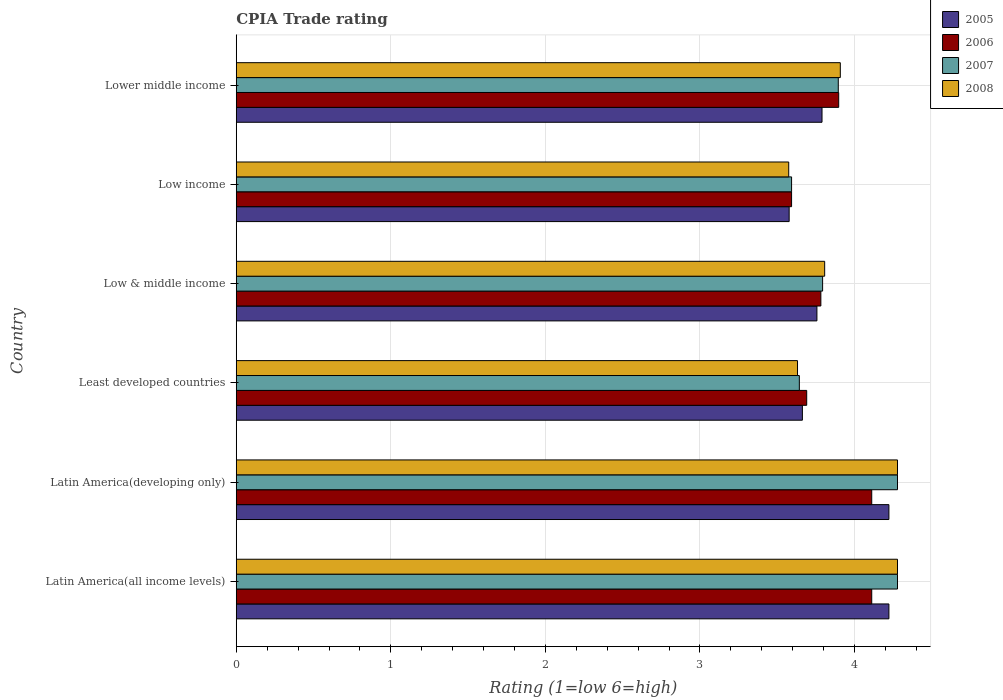Are the number of bars per tick equal to the number of legend labels?
Your answer should be compact. Yes. Are the number of bars on each tick of the Y-axis equal?
Make the answer very short. Yes. How many bars are there on the 5th tick from the top?
Provide a succinct answer. 4. How many bars are there on the 3rd tick from the bottom?
Ensure brevity in your answer.  4. What is the label of the 5th group of bars from the top?
Provide a short and direct response. Latin America(developing only). In how many cases, is the number of bars for a given country not equal to the number of legend labels?
Your answer should be compact. 0. What is the CPIA rating in 2008 in Latin America(all income levels)?
Keep it short and to the point. 4.28. Across all countries, what is the maximum CPIA rating in 2008?
Provide a succinct answer. 4.28. Across all countries, what is the minimum CPIA rating in 2005?
Make the answer very short. 3.58. In which country was the CPIA rating in 2007 maximum?
Provide a succinct answer. Latin America(all income levels). In which country was the CPIA rating in 2005 minimum?
Your answer should be very brief. Low income. What is the total CPIA rating in 2006 in the graph?
Offer a terse response. 23.18. What is the difference between the CPIA rating in 2008 in Low & middle income and that in Low income?
Your response must be concise. 0.23. What is the difference between the CPIA rating in 2007 in Lower middle income and the CPIA rating in 2006 in Low & middle income?
Ensure brevity in your answer.  0.11. What is the average CPIA rating in 2007 per country?
Offer a terse response. 3.91. What is the difference between the CPIA rating in 2007 and CPIA rating in 2008 in Latin America(developing only)?
Provide a short and direct response. 0. What is the ratio of the CPIA rating in 2007 in Low & middle income to that in Lower middle income?
Give a very brief answer. 0.97. Is the CPIA rating in 2005 in Latin America(developing only) less than that in Low income?
Your answer should be very brief. No. Is the difference between the CPIA rating in 2007 in Latin America(all income levels) and Low & middle income greater than the difference between the CPIA rating in 2008 in Latin America(all income levels) and Low & middle income?
Make the answer very short. Yes. What is the difference between the highest and the second highest CPIA rating in 2008?
Your answer should be compact. 0. What is the difference between the highest and the lowest CPIA rating in 2006?
Your answer should be compact. 0.52. In how many countries, is the CPIA rating in 2005 greater than the average CPIA rating in 2005 taken over all countries?
Make the answer very short. 2. Is the sum of the CPIA rating in 2006 in Latin America(developing only) and Least developed countries greater than the maximum CPIA rating in 2005 across all countries?
Your answer should be very brief. Yes. How many bars are there?
Your answer should be very brief. 24. How many countries are there in the graph?
Offer a terse response. 6. Does the graph contain any zero values?
Ensure brevity in your answer.  No. How many legend labels are there?
Keep it short and to the point. 4. How are the legend labels stacked?
Keep it short and to the point. Vertical. What is the title of the graph?
Offer a terse response. CPIA Trade rating. Does "1984" appear as one of the legend labels in the graph?
Your response must be concise. No. What is the label or title of the X-axis?
Provide a short and direct response. Rating (1=low 6=high). What is the Rating (1=low 6=high) in 2005 in Latin America(all income levels)?
Give a very brief answer. 4.22. What is the Rating (1=low 6=high) in 2006 in Latin America(all income levels)?
Give a very brief answer. 4.11. What is the Rating (1=low 6=high) in 2007 in Latin America(all income levels)?
Offer a very short reply. 4.28. What is the Rating (1=low 6=high) of 2008 in Latin America(all income levels)?
Ensure brevity in your answer.  4.28. What is the Rating (1=low 6=high) of 2005 in Latin America(developing only)?
Provide a succinct answer. 4.22. What is the Rating (1=low 6=high) of 2006 in Latin America(developing only)?
Your answer should be compact. 4.11. What is the Rating (1=low 6=high) of 2007 in Latin America(developing only)?
Make the answer very short. 4.28. What is the Rating (1=low 6=high) of 2008 in Latin America(developing only)?
Provide a succinct answer. 4.28. What is the Rating (1=low 6=high) of 2005 in Least developed countries?
Offer a very short reply. 3.66. What is the Rating (1=low 6=high) of 2006 in Least developed countries?
Give a very brief answer. 3.69. What is the Rating (1=low 6=high) of 2007 in Least developed countries?
Keep it short and to the point. 3.64. What is the Rating (1=low 6=high) of 2008 in Least developed countries?
Offer a very short reply. 3.63. What is the Rating (1=low 6=high) of 2005 in Low & middle income?
Ensure brevity in your answer.  3.76. What is the Rating (1=low 6=high) in 2006 in Low & middle income?
Offer a very short reply. 3.78. What is the Rating (1=low 6=high) of 2007 in Low & middle income?
Give a very brief answer. 3.79. What is the Rating (1=low 6=high) in 2008 in Low & middle income?
Your answer should be compact. 3.81. What is the Rating (1=low 6=high) in 2005 in Low income?
Provide a short and direct response. 3.58. What is the Rating (1=low 6=high) in 2006 in Low income?
Ensure brevity in your answer.  3.59. What is the Rating (1=low 6=high) in 2007 in Low income?
Your response must be concise. 3.59. What is the Rating (1=low 6=high) of 2008 in Low income?
Offer a very short reply. 3.57. What is the Rating (1=low 6=high) of 2005 in Lower middle income?
Your response must be concise. 3.79. What is the Rating (1=low 6=high) of 2006 in Lower middle income?
Give a very brief answer. 3.9. What is the Rating (1=low 6=high) of 2007 in Lower middle income?
Offer a very short reply. 3.89. What is the Rating (1=low 6=high) in 2008 in Lower middle income?
Provide a succinct answer. 3.91. Across all countries, what is the maximum Rating (1=low 6=high) in 2005?
Offer a very short reply. 4.22. Across all countries, what is the maximum Rating (1=low 6=high) in 2006?
Offer a very short reply. 4.11. Across all countries, what is the maximum Rating (1=low 6=high) of 2007?
Your response must be concise. 4.28. Across all countries, what is the maximum Rating (1=low 6=high) of 2008?
Offer a very short reply. 4.28. Across all countries, what is the minimum Rating (1=low 6=high) of 2005?
Provide a succinct answer. 3.58. Across all countries, what is the minimum Rating (1=low 6=high) of 2006?
Provide a succinct answer. 3.59. Across all countries, what is the minimum Rating (1=low 6=high) of 2007?
Provide a short and direct response. 3.59. Across all countries, what is the minimum Rating (1=low 6=high) in 2008?
Keep it short and to the point. 3.57. What is the total Rating (1=low 6=high) in 2005 in the graph?
Make the answer very short. 23.23. What is the total Rating (1=low 6=high) in 2006 in the graph?
Make the answer very short. 23.18. What is the total Rating (1=low 6=high) in 2007 in the graph?
Your response must be concise. 23.48. What is the total Rating (1=low 6=high) in 2008 in the graph?
Your answer should be very brief. 23.48. What is the difference between the Rating (1=low 6=high) in 2005 in Latin America(all income levels) and that in Latin America(developing only)?
Provide a succinct answer. 0. What is the difference between the Rating (1=low 6=high) of 2006 in Latin America(all income levels) and that in Latin America(developing only)?
Provide a short and direct response. 0. What is the difference between the Rating (1=low 6=high) in 2008 in Latin America(all income levels) and that in Latin America(developing only)?
Offer a terse response. 0. What is the difference between the Rating (1=low 6=high) in 2005 in Latin America(all income levels) and that in Least developed countries?
Offer a terse response. 0.56. What is the difference between the Rating (1=low 6=high) of 2006 in Latin America(all income levels) and that in Least developed countries?
Make the answer very short. 0.42. What is the difference between the Rating (1=low 6=high) in 2007 in Latin America(all income levels) and that in Least developed countries?
Offer a terse response. 0.63. What is the difference between the Rating (1=low 6=high) in 2008 in Latin America(all income levels) and that in Least developed countries?
Provide a succinct answer. 0.65. What is the difference between the Rating (1=low 6=high) in 2005 in Latin America(all income levels) and that in Low & middle income?
Your answer should be compact. 0.47. What is the difference between the Rating (1=low 6=high) of 2006 in Latin America(all income levels) and that in Low & middle income?
Offer a very short reply. 0.33. What is the difference between the Rating (1=low 6=high) in 2007 in Latin America(all income levels) and that in Low & middle income?
Your response must be concise. 0.48. What is the difference between the Rating (1=low 6=high) of 2008 in Latin America(all income levels) and that in Low & middle income?
Give a very brief answer. 0.47. What is the difference between the Rating (1=low 6=high) of 2005 in Latin America(all income levels) and that in Low income?
Make the answer very short. 0.65. What is the difference between the Rating (1=low 6=high) of 2006 in Latin America(all income levels) and that in Low income?
Your answer should be very brief. 0.52. What is the difference between the Rating (1=low 6=high) in 2007 in Latin America(all income levels) and that in Low income?
Offer a terse response. 0.69. What is the difference between the Rating (1=low 6=high) of 2008 in Latin America(all income levels) and that in Low income?
Provide a succinct answer. 0.7. What is the difference between the Rating (1=low 6=high) of 2005 in Latin America(all income levels) and that in Lower middle income?
Offer a very short reply. 0.43. What is the difference between the Rating (1=low 6=high) in 2006 in Latin America(all income levels) and that in Lower middle income?
Offer a terse response. 0.21. What is the difference between the Rating (1=low 6=high) in 2007 in Latin America(all income levels) and that in Lower middle income?
Keep it short and to the point. 0.38. What is the difference between the Rating (1=low 6=high) of 2008 in Latin America(all income levels) and that in Lower middle income?
Offer a very short reply. 0.37. What is the difference between the Rating (1=low 6=high) in 2005 in Latin America(developing only) and that in Least developed countries?
Your answer should be compact. 0.56. What is the difference between the Rating (1=low 6=high) in 2006 in Latin America(developing only) and that in Least developed countries?
Provide a short and direct response. 0.42. What is the difference between the Rating (1=low 6=high) of 2007 in Latin America(developing only) and that in Least developed countries?
Give a very brief answer. 0.63. What is the difference between the Rating (1=low 6=high) in 2008 in Latin America(developing only) and that in Least developed countries?
Give a very brief answer. 0.65. What is the difference between the Rating (1=low 6=high) in 2005 in Latin America(developing only) and that in Low & middle income?
Your answer should be very brief. 0.47. What is the difference between the Rating (1=low 6=high) of 2006 in Latin America(developing only) and that in Low & middle income?
Provide a succinct answer. 0.33. What is the difference between the Rating (1=low 6=high) in 2007 in Latin America(developing only) and that in Low & middle income?
Keep it short and to the point. 0.48. What is the difference between the Rating (1=low 6=high) in 2008 in Latin America(developing only) and that in Low & middle income?
Provide a short and direct response. 0.47. What is the difference between the Rating (1=low 6=high) of 2005 in Latin America(developing only) and that in Low income?
Your answer should be compact. 0.65. What is the difference between the Rating (1=low 6=high) in 2006 in Latin America(developing only) and that in Low income?
Provide a succinct answer. 0.52. What is the difference between the Rating (1=low 6=high) in 2007 in Latin America(developing only) and that in Low income?
Provide a succinct answer. 0.69. What is the difference between the Rating (1=low 6=high) of 2008 in Latin America(developing only) and that in Low income?
Offer a terse response. 0.7. What is the difference between the Rating (1=low 6=high) in 2005 in Latin America(developing only) and that in Lower middle income?
Give a very brief answer. 0.43. What is the difference between the Rating (1=low 6=high) of 2006 in Latin America(developing only) and that in Lower middle income?
Offer a terse response. 0.21. What is the difference between the Rating (1=low 6=high) of 2007 in Latin America(developing only) and that in Lower middle income?
Keep it short and to the point. 0.38. What is the difference between the Rating (1=low 6=high) of 2008 in Latin America(developing only) and that in Lower middle income?
Provide a short and direct response. 0.37. What is the difference between the Rating (1=low 6=high) in 2005 in Least developed countries and that in Low & middle income?
Provide a short and direct response. -0.09. What is the difference between the Rating (1=low 6=high) in 2006 in Least developed countries and that in Low & middle income?
Your response must be concise. -0.09. What is the difference between the Rating (1=low 6=high) of 2007 in Least developed countries and that in Low & middle income?
Give a very brief answer. -0.15. What is the difference between the Rating (1=low 6=high) in 2008 in Least developed countries and that in Low & middle income?
Provide a succinct answer. -0.18. What is the difference between the Rating (1=low 6=high) in 2005 in Least developed countries and that in Low income?
Offer a terse response. 0.09. What is the difference between the Rating (1=low 6=high) in 2006 in Least developed countries and that in Low income?
Offer a terse response. 0.1. What is the difference between the Rating (1=low 6=high) of 2007 in Least developed countries and that in Low income?
Offer a very short reply. 0.05. What is the difference between the Rating (1=low 6=high) of 2008 in Least developed countries and that in Low income?
Offer a terse response. 0.06. What is the difference between the Rating (1=low 6=high) of 2005 in Least developed countries and that in Lower middle income?
Provide a short and direct response. -0.13. What is the difference between the Rating (1=low 6=high) of 2006 in Least developed countries and that in Lower middle income?
Provide a succinct answer. -0.21. What is the difference between the Rating (1=low 6=high) in 2007 in Least developed countries and that in Lower middle income?
Your answer should be very brief. -0.25. What is the difference between the Rating (1=low 6=high) of 2008 in Least developed countries and that in Lower middle income?
Make the answer very short. -0.28. What is the difference between the Rating (1=low 6=high) in 2005 in Low & middle income and that in Low income?
Offer a terse response. 0.18. What is the difference between the Rating (1=low 6=high) in 2006 in Low & middle income and that in Low income?
Make the answer very short. 0.19. What is the difference between the Rating (1=low 6=high) of 2007 in Low & middle income and that in Low income?
Give a very brief answer. 0.2. What is the difference between the Rating (1=low 6=high) in 2008 in Low & middle income and that in Low income?
Keep it short and to the point. 0.23. What is the difference between the Rating (1=low 6=high) of 2005 in Low & middle income and that in Lower middle income?
Make the answer very short. -0.03. What is the difference between the Rating (1=low 6=high) of 2006 in Low & middle income and that in Lower middle income?
Offer a terse response. -0.12. What is the difference between the Rating (1=low 6=high) in 2007 in Low & middle income and that in Lower middle income?
Your response must be concise. -0.1. What is the difference between the Rating (1=low 6=high) of 2008 in Low & middle income and that in Lower middle income?
Offer a terse response. -0.1. What is the difference between the Rating (1=low 6=high) in 2005 in Low income and that in Lower middle income?
Your answer should be very brief. -0.21. What is the difference between the Rating (1=low 6=high) of 2006 in Low income and that in Lower middle income?
Ensure brevity in your answer.  -0.3. What is the difference between the Rating (1=low 6=high) of 2007 in Low income and that in Lower middle income?
Give a very brief answer. -0.3. What is the difference between the Rating (1=low 6=high) in 2008 in Low income and that in Lower middle income?
Keep it short and to the point. -0.33. What is the difference between the Rating (1=low 6=high) in 2005 in Latin America(all income levels) and the Rating (1=low 6=high) in 2007 in Latin America(developing only)?
Offer a terse response. -0.06. What is the difference between the Rating (1=low 6=high) in 2005 in Latin America(all income levels) and the Rating (1=low 6=high) in 2008 in Latin America(developing only)?
Give a very brief answer. -0.06. What is the difference between the Rating (1=low 6=high) in 2006 in Latin America(all income levels) and the Rating (1=low 6=high) in 2007 in Latin America(developing only)?
Keep it short and to the point. -0.17. What is the difference between the Rating (1=low 6=high) of 2007 in Latin America(all income levels) and the Rating (1=low 6=high) of 2008 in Latin America(developing only)?
Provide a short and direct response. 0. What is the difference between the Rating (1=low 6=high) of 2005 in Latin America(all income levels) and the Rating (1=low 6=high) of 2006 in Least developed countries?
Offer a terse response. 0.53. What is the difference between the Rating (1=low 6=high) in 2005 in Latin America(all income levels) and the Rating (1=low 6=high) in 2007 in Least developed countries?
Give a very brief answer. 0.58. What is the difference between the Rating (1=low 6=high) in 2005 in Latin America(all income levels) and the Rating (1=low 6=high) in 2008 in Least developed countries?
Provide a short and direct response. 0.59. What is the difference between the Rating (1=low 6=high) in 2006 in Latin America(all income levels) and the Rating (1=low 6=high) in 2007 in Least developed countries?
Provide a succinct answer. 0.47. What is the difference between the Rating (1=low 6=high) of 2006 in Latin America(all income levels) and the Rating (1=low 6=high) of 2008 in Least developed countries?
Your answer should be compact. 0.48. What is the difference between the Rating (1=low 6=high) of 2007 in Latin America(all income levels) and the Rating (1=low 6=high) of 2008 in Least developed countries?
Give a very brief answer. 0.65. What is the difference between the Rating (1=low 6=high) in 2005 in Latin America(all income levels) and the Rating (1=low 6=high) in 2006 in Low & middle income?
Provide a succinct answer. 0.44. What is the difference between the Rating (1=low 6=high) of 2005 in Latin America(all income levels) and the Rating (1=low 6=high) of 2007 in Low & middle income?
Keep it short and to the point. 0.43. What is the difference between the Rating (1=low 6=high) in 2005 in Latin America(all income levels) and the Rating (1=low 6=high) in 2008 in Low & middle income?
Your answer should be very brief. 0.42. What is the difference between the Rating (1=low 6=high) in 2006 in Latin America(all income levels) and the Rating (1=low 6=high) in 2007 in Low & middle income?
Your answer should be compact. 0.32. What is the difference between the Rating (1=low 6=high) in 2006 in Latin America(all income levels) and the Rating (1=low 6=high) in 2008 in Low & middle income?
Your response must be concise. 0.3. What is the difference between the Rating (1=low 6=high) in 2007 in Latin America(all income levels) and the Rating (1=low 6=high) in 2008 in Low & middle income?
Your answer should be very brief. 0.47. What is the difference between the Rating (1=low 6=high) in 2005 in Latin America(all income levels) and the Rating (1=low 6=high) in 2006 in Low income?
Give a very brief answer. 0.63. What is the difference between the Rating (1=low 6=high) of 2005 in Latin America(all income levels) and the Rating (1=low 6=high) of 2007 in Low income?
Provide a succinct answer. 0.63. What is the difference between the Rating (1=low 6=high) of 2005 in Latin America(all income levels) and the Rating (1=low 6=high) of 2008 in Low income?
Offer a very short reply. 0.65. What is the difference between the Rating (1=low 6=high) in 2006 in Latin America(all income levels) and the Rating (1=low 6=high) in 2007 in Low income?
Make the answer very short. 0.52. What is the difference between the Rating (1=low 6=high) in 2006 in Latin America(all income levels) and the Rating (1=low 6=high) in 2008 in Low income?
Offer a very short reply. 0.54. What is the difference between the Rating (1=low 6=high) in 2007 in Latin America(all income levels) and the Rating (1=low 6=high) in 2008 in Low income?
Provide a succinct answer. 0.7. What is the difference between the Rating (1=low 6=high) of 2005 in Latin America(all income levels) and the Rating (1=low 6=high) of 2006 in Lower middle income?
Ensure brevity in your answer.  0.32. What is the difference between the Rating (1=low 6=high) in 2005 in Latin America(all income levels) and the Rating (1=low 6=high) in 2007 in Lower middle income?
Provide a short and direct response. 0.33. What is the difference between the Rating (1=low 6=high) of 2005 in Latin America(all income levels) and the Rating (1=low 6=high) of 2008 in Lower middle income?
Ensure brevity in your answer.  0.31. What is the difference between the Rating (1=low 6=high) of 2006 in Latin America(all income levels) and the Rating (1=low 6=high) of 2007 in Lower middle income?
Your response must be concise. 0.22. What is the difference between the Rating (1=low 6=high) of 2006 in Latin America(all income levels) and the Rating (1=low 6=high) of 2008 in Lower middle income?
Offer a terse response. 0.2. What is the difference between the Rating (1=low 6=high) of 2007 in Latin America(all income levels) and the Rating (1=low 6=high) of 2008 in Lower middle income?
Your answer should be compact. 0.37. What is the difference between the Rating (1=low 6=high) of 2005 in Latin America(developing only) and the Rating (1=low 6=high) of 2006 in Least developed countries?
Make the answer very short. 0.53. What is the difference between the Rating (1=low 6=high) in 2005 in Latin America(developing only) and the Rating (1=low 6=high) in 2007 in Least developed countries?
Give a very brief answer. 0.58. What is the difference between the Rating (1=low 6=high) of 2005 in Latin America(developing only) and the Rating (1=low 6=high) of 2008 in Least developed countries?
Your response must be concise. 0.59. What is the difference between the Rating (1=low 6=high) of 2006 in Latin America(developing only) and the Rating (1=low 6=high) of 2007 in Least developed countries?
Your answer should be compact. 0.47. What is the difference between the Rating (1=low 6=high) in 2006 in Latin America(developing only) and the Rating (1=low 6=high) in 2008 in Least developed countries?
Offer a very short reply. 0.48. What is the difference between the Rating (1=low 6=high) of 2007 in Latin America(developing only) and the Rating (1=low 6=high) of 2008 in Least developed countries?
Your answer should be compact. 0.65. What is the difference between the Rating (1=low 6=high) of 2005 in Latin America(developing only) and the Rating (1=low 6=high) of 2006 in Low & middle income?
Your answer should be very brief. 0.44. What is the difference between the Rating (1=low 6=high) in 2005 in Latin America(developing only) and the Rating (1=low 6=high) in 2007 in Low & middle income?
Your answer should be compact. 0.43. What is the difference between the Rating (1=low 6=high) of 2005 in Latin America(developing only) and the Rating (1=low 6=high) of 2008 in Low & middle income?
Your answer should be compact. 0.42. What is the difference between the Rating (1=low 6=high) in 2006 in Latin America(developing only) and the Rating (1=low 6=high) in 2007 in Low & middle income?
Provide a succinct answer. 0.32. What is the difference between the Rating (1=low 6=high) of 2006 in Latin America(developing only) and the Rating (1=low 6=high) of 2008 in Low & middle income?
Offer a very short reply. 0.3. What is the difference between the Rating (1=low 6=high) of 2007 in Latin America(developing only) and the Rating (1=low 6=high) of 2008 in Low & middle income?
Your answer should be compact. 0.47. What is the difference between the Rating (1=low 6=high) of 2005 in Latin America(developing only) and the Rating (1=low 6=high) of 2006 in Low income?
Your response must be concise. 0.63. What is the difference between the Rating (1=low 6=high) in 2005 in Latin America(developing only) and the Rating (1=low 6=high) in 2007 in Low income?
Provide a succinct answer. 0.63. What is the difference between the Rating (1=low 6=high) of 2005 in Latin America(developing only) and the Rating (1=low 6=high) of 2008 in Low income?
Ensure brevity in your answer.  0.65. What is the difference between the Rating (1=low 6=high) in 2006 in Latin America(developing only) and the Rating (1=low 6=high) in 2007 in Low income?
Provide a succinct answer. 0.52. What is the difference between the Rating (1=low 6=high) in 2006 in Latin America(developing only) and the Rating (1=low 6=high) in 2008 in Low income?
Offer a terse response. 0.54. What is the difference between the Rating (1=low 6=high) of 2007 in Latin America(developing only) and the Rating (1=low 6=high) of 2008 in Low income?
Your answer should be compact. 0.7. What is the difference between the Rating (1=low 6=high) in 2005 in Latin America(developing only) and the Rating (1=low 6=high) in 2006 in Lower middle income?
Offer a very short reply. 0.32. What is the difference between the Rating (1=low 6=high) in 2005 in Latin America(developing only) and the Rating (1=low 6=high) in 2007 in Lower middle income?
Make the answer very short. 0.33. What is the difference between the Rating (1=low 6=high) in 2005 in Latin America(developing only) and the Rating (1=low 6=high) in 2008 in Lower middle income?
Give a very brief answer. 0.31. What is the difference between the Rating (1=low 6=high) of 2006 in Latin America(developing only) and the Rating (1=low 6=high) of 2007 in Lower middle income?
Ensure brevity in your answer.  0.22. What is the difference between the Rating (1=low 6=high) in 2006 in Latin America(developing only) and the Rating (1=low 6=high) in 2008 in Lower middle income?
Your answer should be compact. 0.2. What is the difference between the Rating (1=low 6=high) in 2007 in Latin America(developing only) and the Rating (1=low 6=high) in 2008 in Lower middle income?
Provide a short and direct response. 0.37. What is the difference between the Rating (1=low 6=high) in 2005 in Least developed countries and the Rating (1=low 6=high) in 2006 in Low & middle income?
Your response must be concise. -0.12. What is the difference between the Rating (1=low 6=high) of 2005 in Least developed countries and the Rating (1=low 6=high) of 2007 in Low & middle income?
Offer a very short reply. -0.13. What is the difference between the Rating (1=low 6=high) of 2005 in Least developed countries and the Rating (1=low 6=high) of 2008 in Low & middle income?
Provide a short and direct response. -0.14. What is the difference between the Rating (1=low 6=high) in 2006 in Least developed countries and the Rating (1=low 6=high) in 2007 in Low & middle income?
Offer a very short reply. -0.1. What is the difference between the Rating (1=low 6=high) in 2006 in Least developed countries and the Rating (1=low 6=high) in 2008 in Low & middle income?
Provide a succinct answer. -0.12. What is the difference between the Rating (1=low 6=high) in 2007 in Least developed countries and the Rating (1=low 6=high) in 2008 in Low & middle income?
Offer a terse response. -0.16. What is the difference between the Rating (1=low 6=high) of 2005 in Least developed countries and the Rating (1=low 6=high) of 2006 in Low income?
Keep it short and to the point. 0.07. What is the difference between the Rating (1=low 6=high) in 2005 in Least developed countries and the Rating (1=low 6=high) in 2007 in Low income?
Your answer should be very brief. 0.07. What is the difference between the Rating (1=low 6=high) in 2005 in Least developed countries and the Rating (1=low 6=high) in 2008 in Low income?
Keep it short and to the point. 0.09. What is the difference between the Rating (1=low 6=high) in 2006 in Least developed countries and the Rating (1=low 6=high) in 2007 in Low income?
Your answer should be very brief. 0.1. What is the difference between the Rating (1=low 6=high) in 2006 in Least developed countries and the Rating (1=low 6=high) in 2008 in Low income?
Your answer should be compact. 0.12. What is the difference between the Rating (1=low 6=high) of 2007 in Least developed countries and the Rating (1=low 6=high) of 2008 in Low income?
Keep it short and to the point. 0.07. What is the difference between the Rating (1=low 6=high) of 2005 in Least developed countries and the Rating (1=low 6=high) of 2006 in Lower middle income?
Your answer should be very brief. -0.23. What is the difference between the Rating (1=low 6=high) of 2005 in Least developed countries and the Rating (1=low 6=high) of 2007 in Lower middle income?
Ensure brevity in your answer.  -0.23. What is the difference between the Rating (1=low 6=high) in 2005 in Least developed countries and the Rating (1=low 6=high) in 2008 in Lower middle income?
Your answer should be very brief. -0.25. What is the difference between the Rating (1=low 6=high) of 2006 in Least developed countries and the Rating (1=low 6=high) of 2007 in Lower middle income?
Provide a succinct answer. -0.2. What is the difference between the Rating (1=low 6=high) of 2006 in Least developed countries and the Rating (1=low 6=high) of 2008 in Lower middle income?
Your response must be concise. -0.22. What is the difference between the Rating (1=low 6=high) of 2007 in Least developed countries and the Rating (1=low 6=high) of 2008 in Lower middle income?
Keep it short and to the point. -0.27. What is the difference between the Rating (1=low 6=high) of 2005 in Low & middle income and the Rating (1=low 6=high) of 2006 in Low income?
Make the answer very short. 0.16. What is the difference between the Rating (1=low 6=high) in 2005 in Low & middle income and the Rating (1=low 6=high) in 2007 in Low income?
Make the answer very short. 0.16. What is the difference between the Rating (1=low 6=high) in 2005 in Low & middle income and the Rating (1=low 6=high) in 2008 in Low income?
Offer a very short reply. 0.18. What is the difference between the Rating (1=low 6=high) of 2006 in Low & middle income and the Rating (1=low 6=high) of 2007 in Low income?
Ensure brevity in your answer.  0.19. What is the difference between the Rating (1=low 6=high) of 2006 in Low & middle income and the Rating (1=low 6=high) of 2008 in Low income?
Make the answer very short. 0.21. What is the difference between the Rating (1=low 6=high) of 2007 in Low & middle income and the Rating (1=low 6=high) of 2008 in Low income?
Give a very brief answer. 0.22. What is the difference between the Rating (1=low 6=high) of 2005 in Low & middle income and the Rating (1=low 6=high) of 2006 in Lower middle income?
Your answer should be very brief. -0.14. What is the difference between the Rating (1=low 6=high) of 2005 in Low & middle income and the Rating (1=low 6=high) of 2007 in Lower middle income?
Offer a terse response. -0.14. What is the difference between the Rating (1=low 6=high) of 2005 in Low & middle income and the Rating (1=low 6=high) of 2008 in Lower middle income?
Make the answer very short. -0.15. What is the difference between the Rating (1=low 6=high) of 2006 in Low & middle income and the Rating (1=low 6=high) of 2007 in Lower middle income?
Keep it short and to the point. -0.11. What is the difference between the Rating (1=low 6=high) of 2006 in Low & middle income and the Rating (1=low 6=high) of 2008 in Lower middle income?
Your response must be concise. -0.13. What is the difference between the Rating (1=low 6=high) of 2007 in Low & middle income and the Rating (1=low 6=high) of 2008 in Lower middle income?
Provide a succinct answer. -0.11. What is the difference between the Rating (1=low 6=high) of 2005 in Low income and the Rating (1=low 6=high) of 2006 in Lower middle income?
Keep it short and to the point. -0.32. What is the difference between the Rating (1=low 6=high) in 2005 in Low income and the Rating (1=low 6=high) in 2007 in Lower middle income?
Your answer should be compact. -0.32. What is the difference between the Rating (1=low 6=high) in 2005 in Low income and the Rating (1=low 6=high) in 2008 in Lower middle income?
Keep it short and to the point. -0.33. What is the difference between the Rating (1=low 6=high) in 2006 in Low income and the Rating (1=low 6=high) in 2007 in Lower middle income?
Offer a terse response. -0.3. What is the difference between the Rating (1=low 6=high) of 2006 in Low income and the Rating (1=low 6=high) of 2008 in Lower middle income?
Your answer should be very brief. -0.32. What is the difference between the Rating (1=low 6=high) in 2007 in Low income and the Rating (1=low 6=high) in 2008 in Lower middle income?
Give a very brief answer. -0.32. What is the average Rating (1=low 6=high) of 2005 per country?
Provide a succinct answer. 3.87. What is the average Rating (1=low 6=high) in 2006 per country?
Ensure brevity in your answer.  3.86. What is the average Rating (1=low 6=high) of 2007 per country?
Make the answer very short. 3.91. What is the average Rating (1=low 6=high) of 2008 per country?
Keep it short and to the point. 3.91. What is the difference between the Rating (1=low 6=high) in 2005 and Rating (1=low 6=high) in 2007 in Latin America(all income levels)?
Your response must be concise. -0.06. What is the difference between the Rating (1=low 6=high) in 2005 and Rating (1=low 6=high) in 2008 in Latin America(all income levels)?
Provide a succinct answer. -0.06. What is the difference between the Rating (1=low 6=high) in 2006 and Rating (1=low 6=high) in 2008 in Latin America(all income levels)?
Give a very brief answer. -0.17. What is the difference between the Rating (1=low 6=high) of 2007 and Rating (1=low 6=high) of 2008 in Latin America(all income levels)?
Make the answer very short. 0. What is the difference between the Rating (1=low 6=high) of 2005 and Rating (1=low 6=high) of 2006 in Latin America(developing only)?
Provide a short and direct response. 0.11. What is the difference between the Rating (1=low 6=high) of 2005 and Rating (1=low 6=high) of 2007 in Latin America(developing only)?
Your answer should be very brief. -0.06. What is the difference between the Rating (1=low 6=high) in 2005 and Rating (1=low 6=high) in 2008 in Latin America(developing only)?
Offer a very short reply. -0.06. What is the difference between the Rating (1=low 6=high) of 2005 and Rating (1=low 6=high) of 2006 in Least developed countries?
Ensure brevity in your answer.  -0.03. What is the difference between the Rating (1=low 6=high) of 2005 and Rating (1=low 6=high) of 2007 in Least developed countries?
Your answer should be very brief. 0.02. What is the difference between the Rating (1=low 6=high) in 2005 and Rating (1=low 6=high) in 2008 in Least developed countries?
Offer a terse response. 0.03. What is the difference between the Rating (1=low 6=high) of 2006 and Rating (1=low 6=high) of 2007 in Least developed countries?
Your answer should be very brief. 0.05. What is the difference between the Rating (1=low 6=high) of 2006 and Rating (1=low 6=high) of 2008 in Least developed countries?
Make the answer very short. 0.06. What is the difference between the Rating (1=low 6=high) in 2007 and Rating (1=low 6=high) in 2008 in Least developed countries?
Offer a very short reply. 0.01. What is the difference between the Rating (1=low 6=high) of 2005 and Rating (1=low 6=high) of 2006 in Low & middle income?
Keep it short and to the point. -0.03. What is the difference between the Rating (1=low 6=high) of 2005 and Rating (1=low 6=high) of 2007 in Low & middle income?
Offer a terse response. -0.04. What is the difference between the Rating (1=low 6=high) of 2005 and Rating (1=low 6=high) of 2008 in Low & middle income?
Your answer should be compact. -0.05. What is the difference between the Rating (1=low 6=high) of 2006 and Rating (1=low 6=high) of 2007 in Low & middle income?
Offer a very short reply. -0.01. What is the difference between the Rating (1=low 6=high) of 2006 and Rating (1=low 6=high) of 2008 in Low & middle income?
Offer a terse response. -0.02. What is the difference between the Rating (1=low 6=high) in 2007 and Rating (1=low 6=high) in 2008 in Low & middle income?
Give a very brief answer. -0.01. What is the difference between the Rating (1=low 6=high) in 2005 and Rating (1=low 6=high) in 2006 in Low income?
Keep it short and to the point. -0.02. What is the difference between the Rating (1=low 6=high) in 2005 and Rating (1=low 6=high) in 2007 in Low income?
Give a very brief answer. -0.02. What is the difference between the Rating (1=low 6=high) of 2005 and Rating (1=low 6=high) of 2008 in Low income?
Provide a succinct answer. 0. What is the difference between the Rating (1=low 6=high) of 2006 and Rating (1=low 6=high) of 2007 in Low income?
Your response must be concise. 0. What is the difference between the Rating (1=low 6=high) of 2006 and Rating (1=low 6=high) of 2008 in Low income?
Your response must be concise. 0.02. What is the difference between the Rating (1=low 6=high) of 2007 and Rating (1=low 6=high) of 2008 in Low income?
Make the answer very short. 0.02. What is the difference between the Rating (1=low 6=high) of 2005 and Rating (1=low 6=high) of 2006 in Lower middle income?
Provide a succinct answer. -0.11. What is the difference between the Rating (1=low 6=high) of 2005 and Rating (1=low 6=high) of 2007 in Lower middle income?
Ensure brevity in your answer.  -0.11. What is the difference between the Rating (1=low 6=high) in 2005 and Rating (1=low 6=high) in 2008 in Lower middle income?
Your answer should be compact. -0.12. What is the difference between the Rating (1=low 6=high) of 2006 and Rating (1=low 6=high) of 2007 in Lower middle income?
Your response must be concise. 0. What is the difference between the Rating (1=low 6=high) in 2006 and Rating (1=low 6=high) in 2008 in Lower middle income?
Provide a short and direct response. -0.01. What is the difference between the Rating (1=low 6=high) of 2007 and Rating (1=low 6=high) of 2008 in Lower middle income?
Your answer should be very brief. -0.01. What is the ratio of the Rating (1=low 6=high) of 2006 in Latin America(all income levels) to that in Latin America(developing only)?
Ensure brevity in your answer.  1. What is the ratio of the Rating (1=low 6=high) of 2008 in Latin America(all income levels) to that in Latin America(developing only)?
Offer a very short reply. 1. What is the ratio of the Rating (1=low 6=high) in 2005 in Latin America(all income levels) to that in Least developed countries?
Provide a short and direct response. 1.15. What is the ratio of the Rating (1=low 6=high) in 2006 in Latin America(all income levels) to that in Least developed countries?
Keep it short and to the point. 1.11. What is the ratio of the Rating (1=low 6=high) in 2007 in Latin America(all income levels) to that in Least developed countries?
Your answer should be compact. 1.17. What is the ratio of the Rating (1=low 6=high) of 2008 in Latin America(all income levels) to that in Least developed countries?
Your answer should be compact. 1.18. What is the ratio of the Rating (1=low 6=high) of 2005 in Latin America(all income levels) to that in Low & middle income?
Give a very brief answer. 1.12. What is the ratio of the Rating (1=low 6=high) of 2006 in Latin America(all income levels) to that in Low & middle income?
Ensure brevity in your answer.  1.09. What is the ratio of the Rating (1=low 6=high) of 2007 in Latin America(all income levels) to that in Low & middle income?
Offer a very short reply. 1.13. What is the ratio of the Rating (1=low 6=high) in 2008 in Latin America(all income levels) to that in Low & middle income?
Provide a succinct answer. 1.12. What is the ratio of the Rating (1=low 6=high) of 2005 in Latin America(all income levels) to that in Low income?
Make the answer very short. 1.18. What is the ratio of the Rating (1=low 6=high) of 2006 in Latin America(all income levels) to that in Low income?
Offer a very short reply. 1.14. What is the ratio of the Rating (1=low 6=high) in 2007 in Latin America(all income levels) to that in Low income?
Give a very brief answer. 1.19. What is the ratio of the Rating (1=low 6=high) of 2008 in Latin America(all income levels) to that in Low income?
Provide a succinct answer. 1.2. What is the ratio of the Rating (1=low 6=high) of 2005 in Latin America(all income levels) to that in Lower middle income?
Ensure brevity in your answer.  1.11. What is the ratio of the Rating (1=low 6=high) of 2006 in Latin America(all income levels) to that in Lower middle income?
Offer a very short reply. 1.05. What is the ratio of the Rating (1=low 6=high) of 2007 in Latin America(all income levels) to that in Lower middle income?
Make the answer very short. 1.1. What is the ratio of the Rating (1=low 6=high) in 2008 in Latin America(all income levels) to that in Lower middle income?
Ensure brevity in your answer.  1.09. What is the ratio of the Rating (1=low 6=high) of 2005 in Latin America(developing only) to that in Least developed countries?
Provide a succinct answer. 1.15. What is the ratio of the Rating (1=low 6=high) in 2006 in Latin America(developing only) to that in Least developed countries?
Keep it short and to the point. 1.11. What is the ratio of the Rating (1=low 6=high) in 2007 in Latin America(developing only) to that in Least developed countries?
Give a very brief answer. 1.17. What is the ratio of the Rating (1=low 6=high) in 2008 in Latin America(developing only) to that in Least developed countries?
Offer a terse response. 1.18. What is the ratio of the Rating (1=low 6=high) in 2005 in Latin America(developing only) to that in Low & middle income?
Your response must be concise. 1.12. What is the ratio of the Rating (1=low 6=high) in 2006 in Latin America(developing only) to that in Low & middle income?
Offer a very short reply. 1.09. What is the ratio of the Rating (1=low 6=high) in 2007 in Latin America(developing only) to that in Low & middle income?
Offer a very short reply. 1.13. What is the ratio of the Rating (1=low 6=high) of 2008 in Latin America(developing only) to that in Low & middle income?
Offer a terse response. 1.12. What is the ratio of the Rating (1=low 6=high) in 2005 in Latin America(developing only) to that in Low income?
Your response must be concise. 1.18. What is the ratio of the Rating (1=low 6=high) of 2006 in Latin America(developing only) to that in Low income?
Offer a very short reply. 1.14. What is the ratio of the Rating (1=low 6=high) of 2007 in Latin America(developing only) to that in Low income?
Give a very brief answer. 1.19. What is the ratio of the Rating (1=low 6=high) in 2008 in Latin America(developing only) to that in Low income?
Offer a terse response. 1.2. What is the ratio of the Rating (1=low 6=high) in 2005 in Latin America(developing only) to that in Lower middle income?
Provide a succinct answer. 1.11. What is the ratio of the Rating (1=low 6=high) in 2006 in Latin America(developing only) to that in Lower middle income?
Your answer should be very brief. 1.05. What is the ratio of the Rating (1=low 6=high) in 2007 in Latin America(developing only) to that in Lower middle income?
Provide a short and direct response. 1.1. What is the ratio of the Rating (1=low 6=high) in 2008 in Latin America(developing only) to that in Lower middle income?
Your answer should be very brief. 1.09. What is the ratio of the Rating (1=low 6=high) of 2006 in Least developed countries to that in Low & middle income?
Your response must be concise. 0.98. What is the ratio of the Rating (1=low 6=high) of 2007 in Least developed countries to that in Low & middle income?
Ensure brevity in your answer.  0.96. What is the ratio of the Rating (1=low 6=high) in 2008 in Least developed countries to that in Low & middle income?
Your response must be concise. 0.95. What is the ratio of the Rating (1=low 6=high) in 2005 in Least developed countries to that in Low income?
Provide a short and direct response. 1.02. What is the ratio of the Rating (1=low 6=high) of 2006 in Least developed countries to that in Low income?
Offer a very short reply. 1.03. What is the ratio of the Rating (1=low 6=high) in 2007 in Least developed countries to that in Low income?
Your response must be concise. 1.01. What is the ratio of the Rating (1=low 6=high) of 2008 in Least developed countries to that in Low income?
Your response must be concise. 1.02. What is the ratio of the Rating (1=low 6=high) in 2005 in Least developed countries to that in Lower middle income?
Your response must be concise. 0.97. What is the ratio of the Rating (1=low 6=high) in 2006 in Least developed countries to that in Lower middle income?
Offer a very short reply. 0.95. What is the ratio of the Rating (1=low 6=high) of 2007 in Least developed countries to that in Lower middle income?
Your answer should be very brief. 0.94. What is the ratio of the Rating (1=low 6=high) of 2008 in Least developed countries to that in Lower middle income?
Give a very brief answer. 0.93. What is the ratio of the Rating (1=low 6=high) in 2005 in Low & middle income to that in Low income?
Make the answer very short. 1.05. What is the ratio of the Rating (1=low 6=high) of 2006 in Low & middle income to that in Low income?
Keep it short and to the point. 1.05. What is the ratio of the Rating (1=low 6=high) of 2007 in Low & middle income to that in Low income?
Offer a very short reply. 1.06. What is the ratio of the Rating (1=low 6=high) in 2008 in Low & middle income to that in Low income?
Provide a short and direct response. 1.07. What is the ratio of the Rating (1=low 6=high) in 2006 in Low & middle income to that in Lower middle income?
Give a very brief answer. 0.97. What is the ratio of the Rating (1=low 6=high) in 2007 in Low & middle income to that in Lower middle income?
Make the answer very short. 0.97. What is the ratio of the Rating (1=low 6=high) of 2008 in Low & middle income to that in Lower middle income?
Your answer should be compact. 0.97. What is the ratio of the Rating (1=low 6=high) of 2005 in Low income to that in Lower middle income?
Keep it short and to the point. 0.94. What is the ratio of the Rating (1=low 6=high) of 2006 in Low income to that in Lower middle income?
Ensure brevity in your answer.  0.92. What is the ratio of the Rating (1=low 6=high) in 2007 in Low income to that in Lower middle income?
Offer a very short reply. 0.92. What is the ratio of the Rating (1=low 6=high) of 2008 in Low income to that in Lower middle income?
Keep it short and to the point. 0.91. What is the difference between the highest and the second highest Rating (1=low 6=high) in 2007?
Provide a short and direct response. 0. What is the difference between the highest and the second highest Rating (1=low 6=high) in 2008?
Offer a terse response. 0. What is the difference between the highest and the lowest Rating (1=low 6=high) in 2005?
Keep it short and to the point. 0.65. What is the difference between the highest and the lowest Rating (1=low 6=high) of 2006?
Keep it short and to the point. 0.52. What is the difference between the highest and the lowest Rating (1=low 6=high) of 2007?
Offer a very short reply. 0.69. What is the difference between the highest and the lowest Rating (1=low 6=high) in 2008?
Provide a short and direct response. 0.7. 